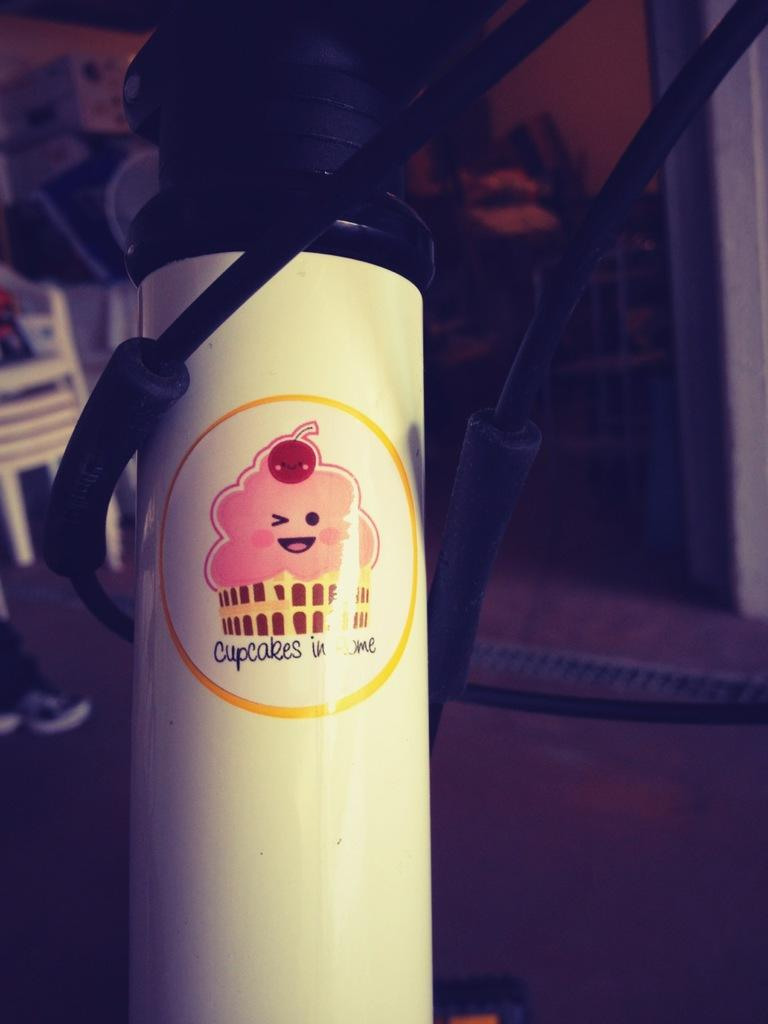<image>
Describe the image concisely. A bottle that says cupcakes in Rome on it 